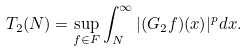<formula> <loc_0><loc_0><loc_500><loc_500>T _ { 2 } ( N ) = \sup _ { f \in F } \int ^ { \infty } _ { N } | ( G _ { 2 } f ) ( x ) | ^ { p } d x .</formula> 